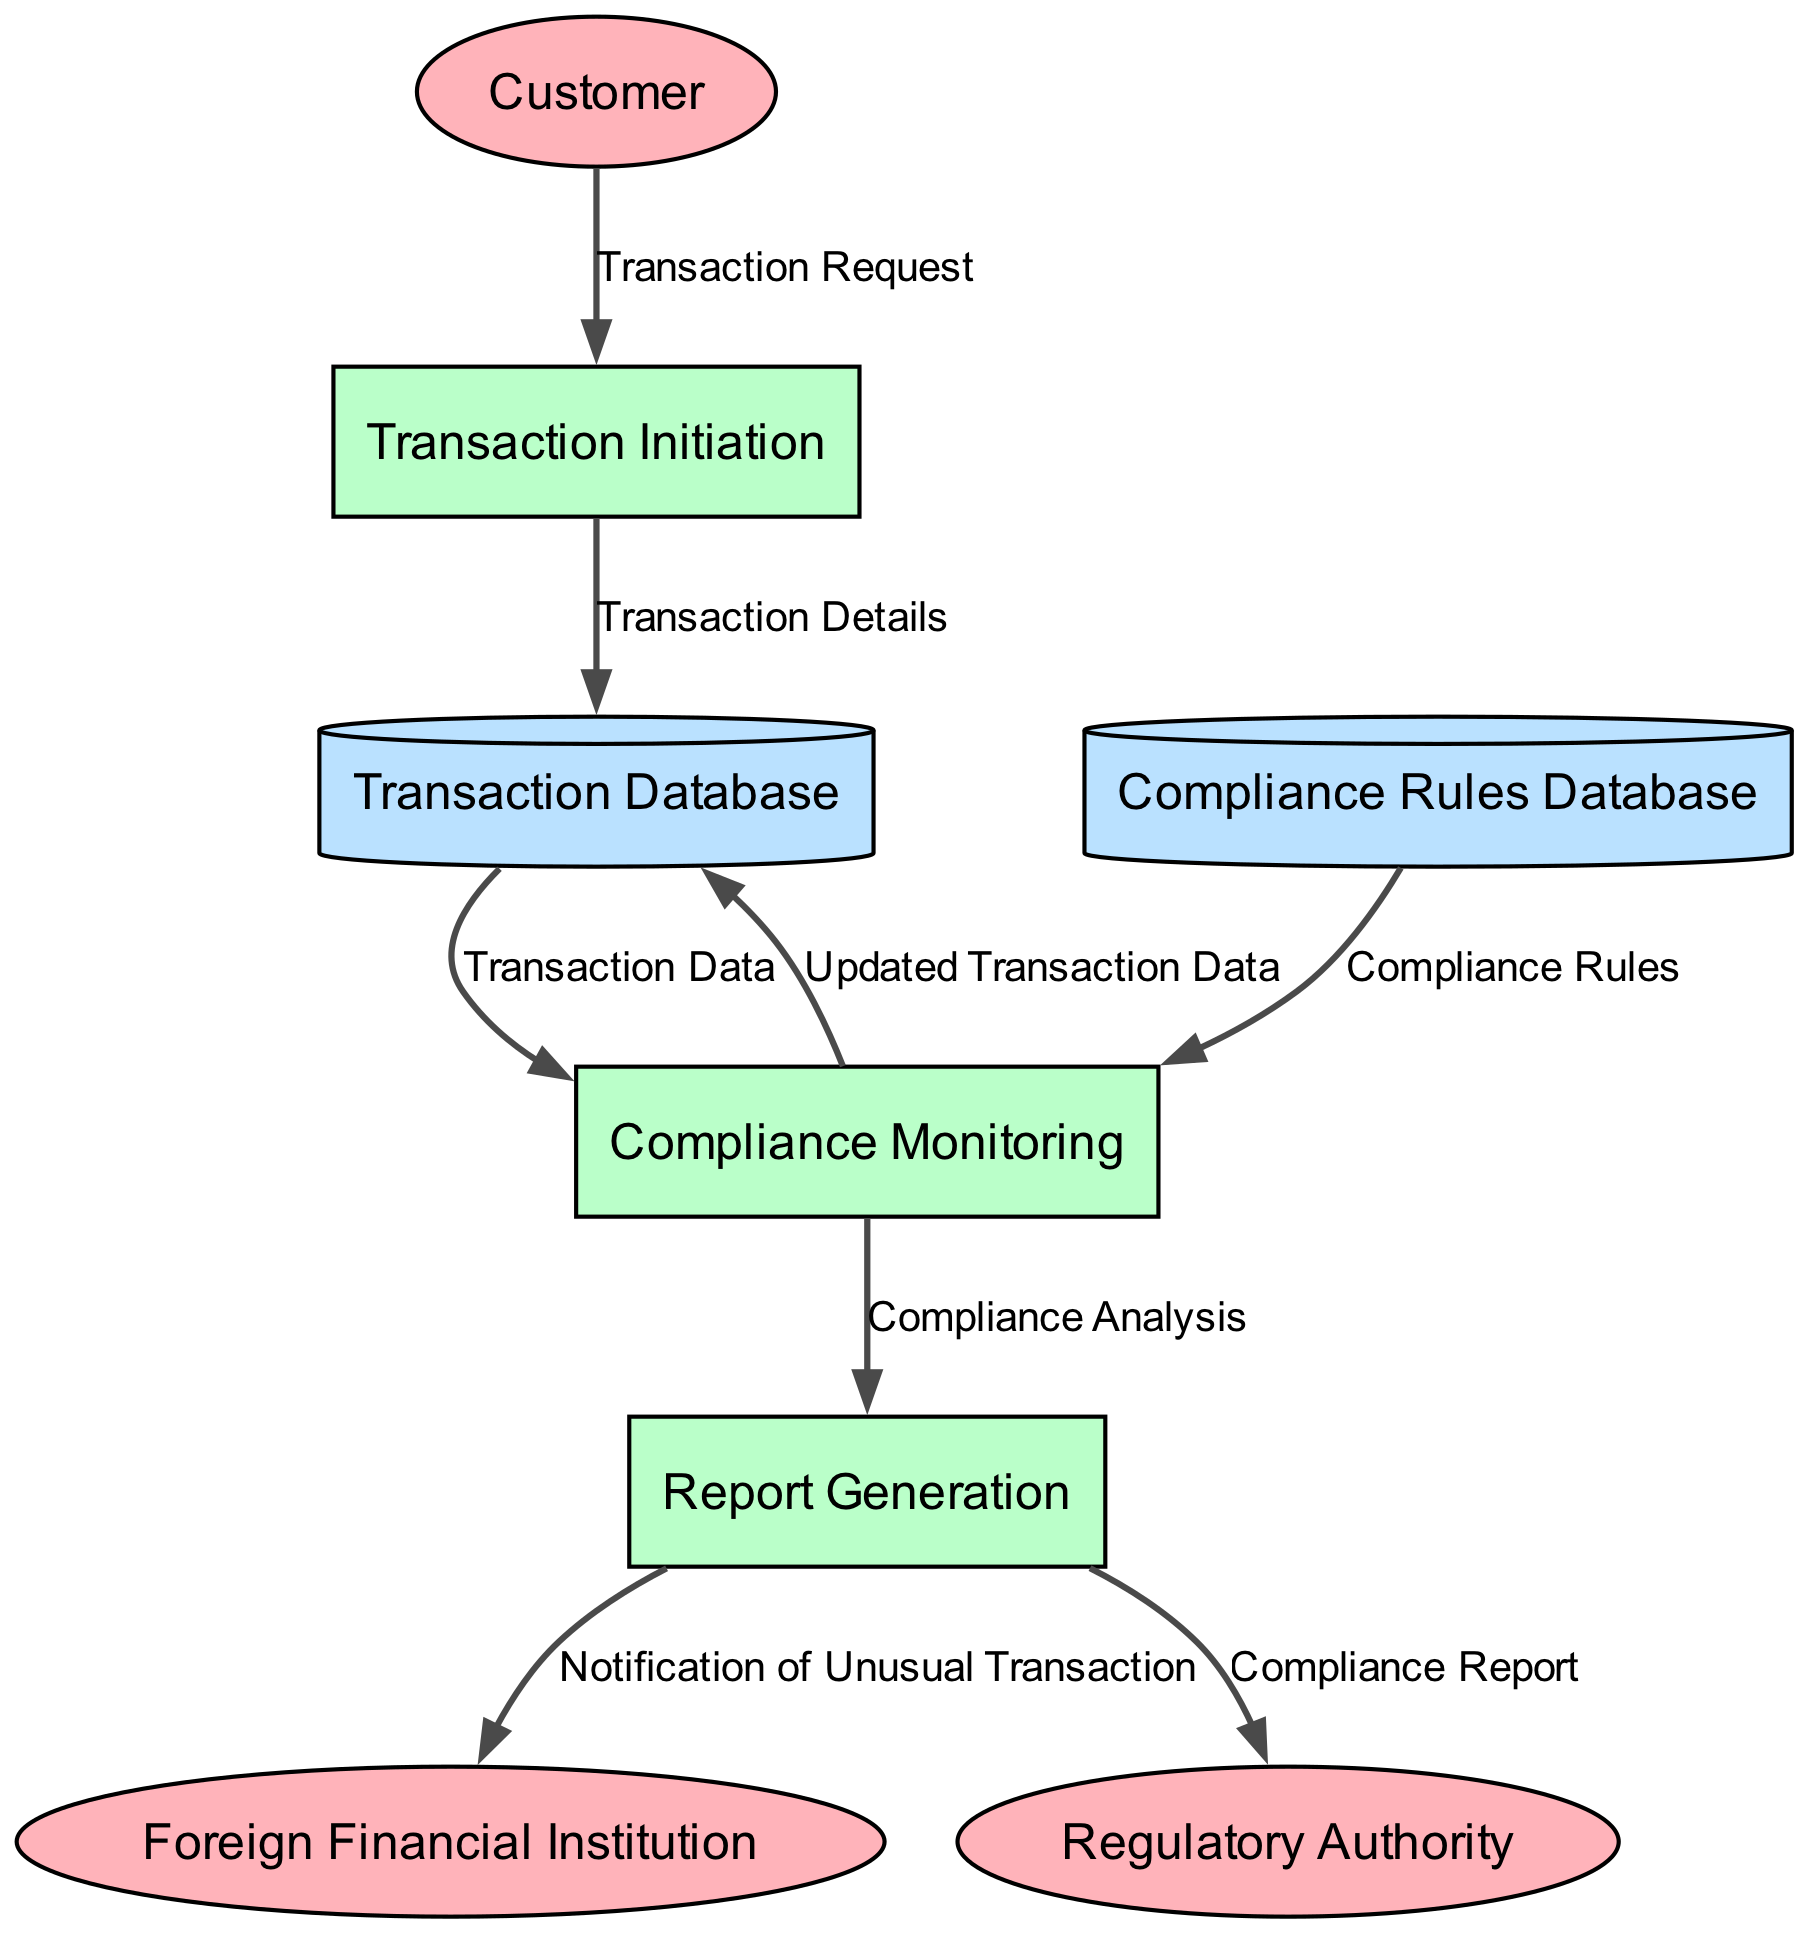what are the external entities in the diagram? The external entities are identified as "Customer" and "Foreign Financial Institution," which are outside the system and interact with it.
Answer: Customer, Foreign Financial Institution how many processes are represented in the diagram? The diagram shows three processes, including "Transaction Initiation," "Compliance Monitoring," and "Report Generation."
Answer: 3 which process captures transaction requests? The process responsible for capturing transaction requests is "Transaction Initiation."
Answer: Transaction Initiation what type of data does the "Compliance Monitoring" process receive from the "Transaction Database"? The data flow from the "Transaction Database" to "Compliance Monitoring" is labeled as "Transaction Data," which includes details of the transactions for analysis.
Answer: Transaction Data what does the "Report Generation" process produce for the "Regulatory Authority"? The "Report Generation" process produces a "Compliance Report" for the "Regulatory Authority" as part of the compliance oversight.
Answer: Compliance Report which data store contains regulatory rules? The data store that contains regulatory rules is the "Compliance Rules Database."
Answer: Compliance Rules Database what is the function of the "Compliance Monitoring" process? The function of the "Compliance Monitoring" process is to analyze transaction data to detect unusual activities and ensure compliance with regulations.
Answer: Analyzes transaction data how does the "Compliance Monitoring" process interact with the "Transaction Database"? The "Compliance Monitoring" process sends "Updated Transaction Data" back to the "Transaction Database" after analysis.
Answer: Updated Transaction Data how many data flows connect the "Report Generation" process to other entities? The "Report Generation" process connects to two entities: the "Regulatory Authority" and "Foreign Financial Institution," resulting in two data flows.
Answer: 2 